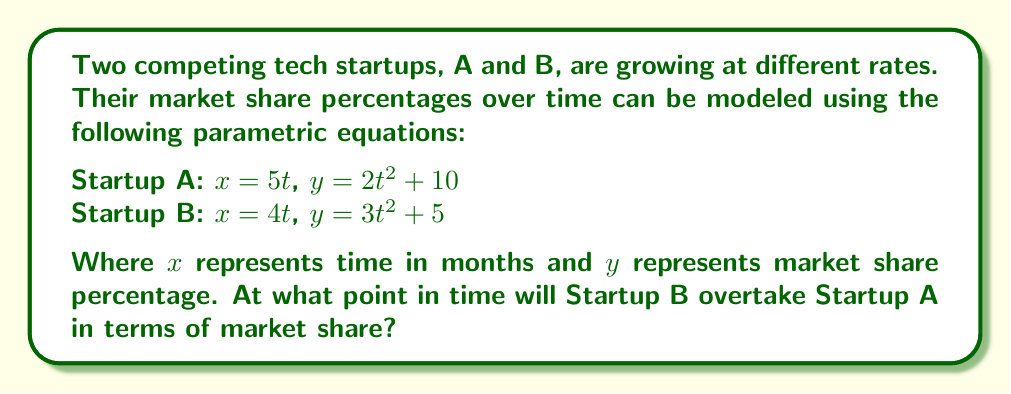Help me with this question. To solve this problem, we need to find the point where the market shares of both startups are equal. This occurs when their $y$ values are the same for a given $x$ value.

1) First, we need to eliminate the parameter $t$ from each set of equations:

   For Startup A: $t = \frac{x}{5}$
   Substituting this into the $y$ equation:
   $y_A = 2(\frac{x}{5})^2 + 10 = \frac{2x^2}{25} + 10$

   For Startup B: $t = \frac{x}{4}$
   Substituting this into the $y$ equation:
   $y_B = 3(\frac{x}{4})^2 + 5 = \frac{3x^2}{16} + 5$

2) Now we can set these equations equal to each other:

   $\frac{2x^2}{25} + 10 = \frac{3x^2}{16} + 5$

3) Solving for $x$:

   $\frac{2x^2}{25} - \frac{3x^2}{16} = -5$
   $\frac{32x^2}{400} - \frac{75x^2}{400} = -5$
   $\frac{-43x^2}{400} = -5$
   $x^2 = \frac{2000}{43}$
   $x = \sqrt{\frac{2000}{43}} \approx 6.82$ months

4) To find the market share at this point, we can substitute this $x$ value back into either of the original parametric equations. Let's use Startup A's equations:

   $t = \frac{x}{5} = \frac{6.82}{5} \approx 1.364$
   $y = 2(1.364)^2 + 10 \approx 13.72\%$

Therefore, Startup B will overtake Startup A after approximately 6.82 months, when both have a market share of about 13.72%.
Answer: Startup B will overtake Startup A after approximately 6.82 months, when both have a market share of about 13.72%. 